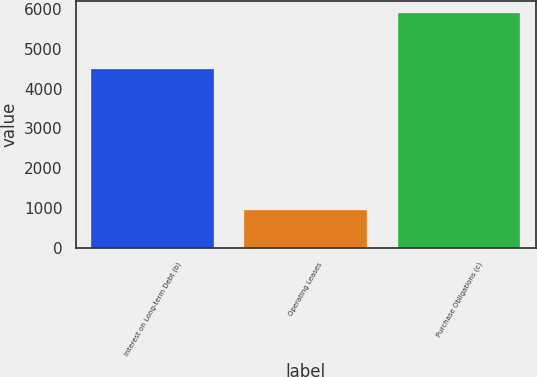Convert chart. <chart><loc_0><loc_0><loc_500><loc_500><bar_chart><fcel>Interest on Long-term Debt (b)<fcel>Operating Leases<fcel>Purchase Obligations (c)<nl><fcel>4497<fcel>968<fcel>5896<nl></chart> 